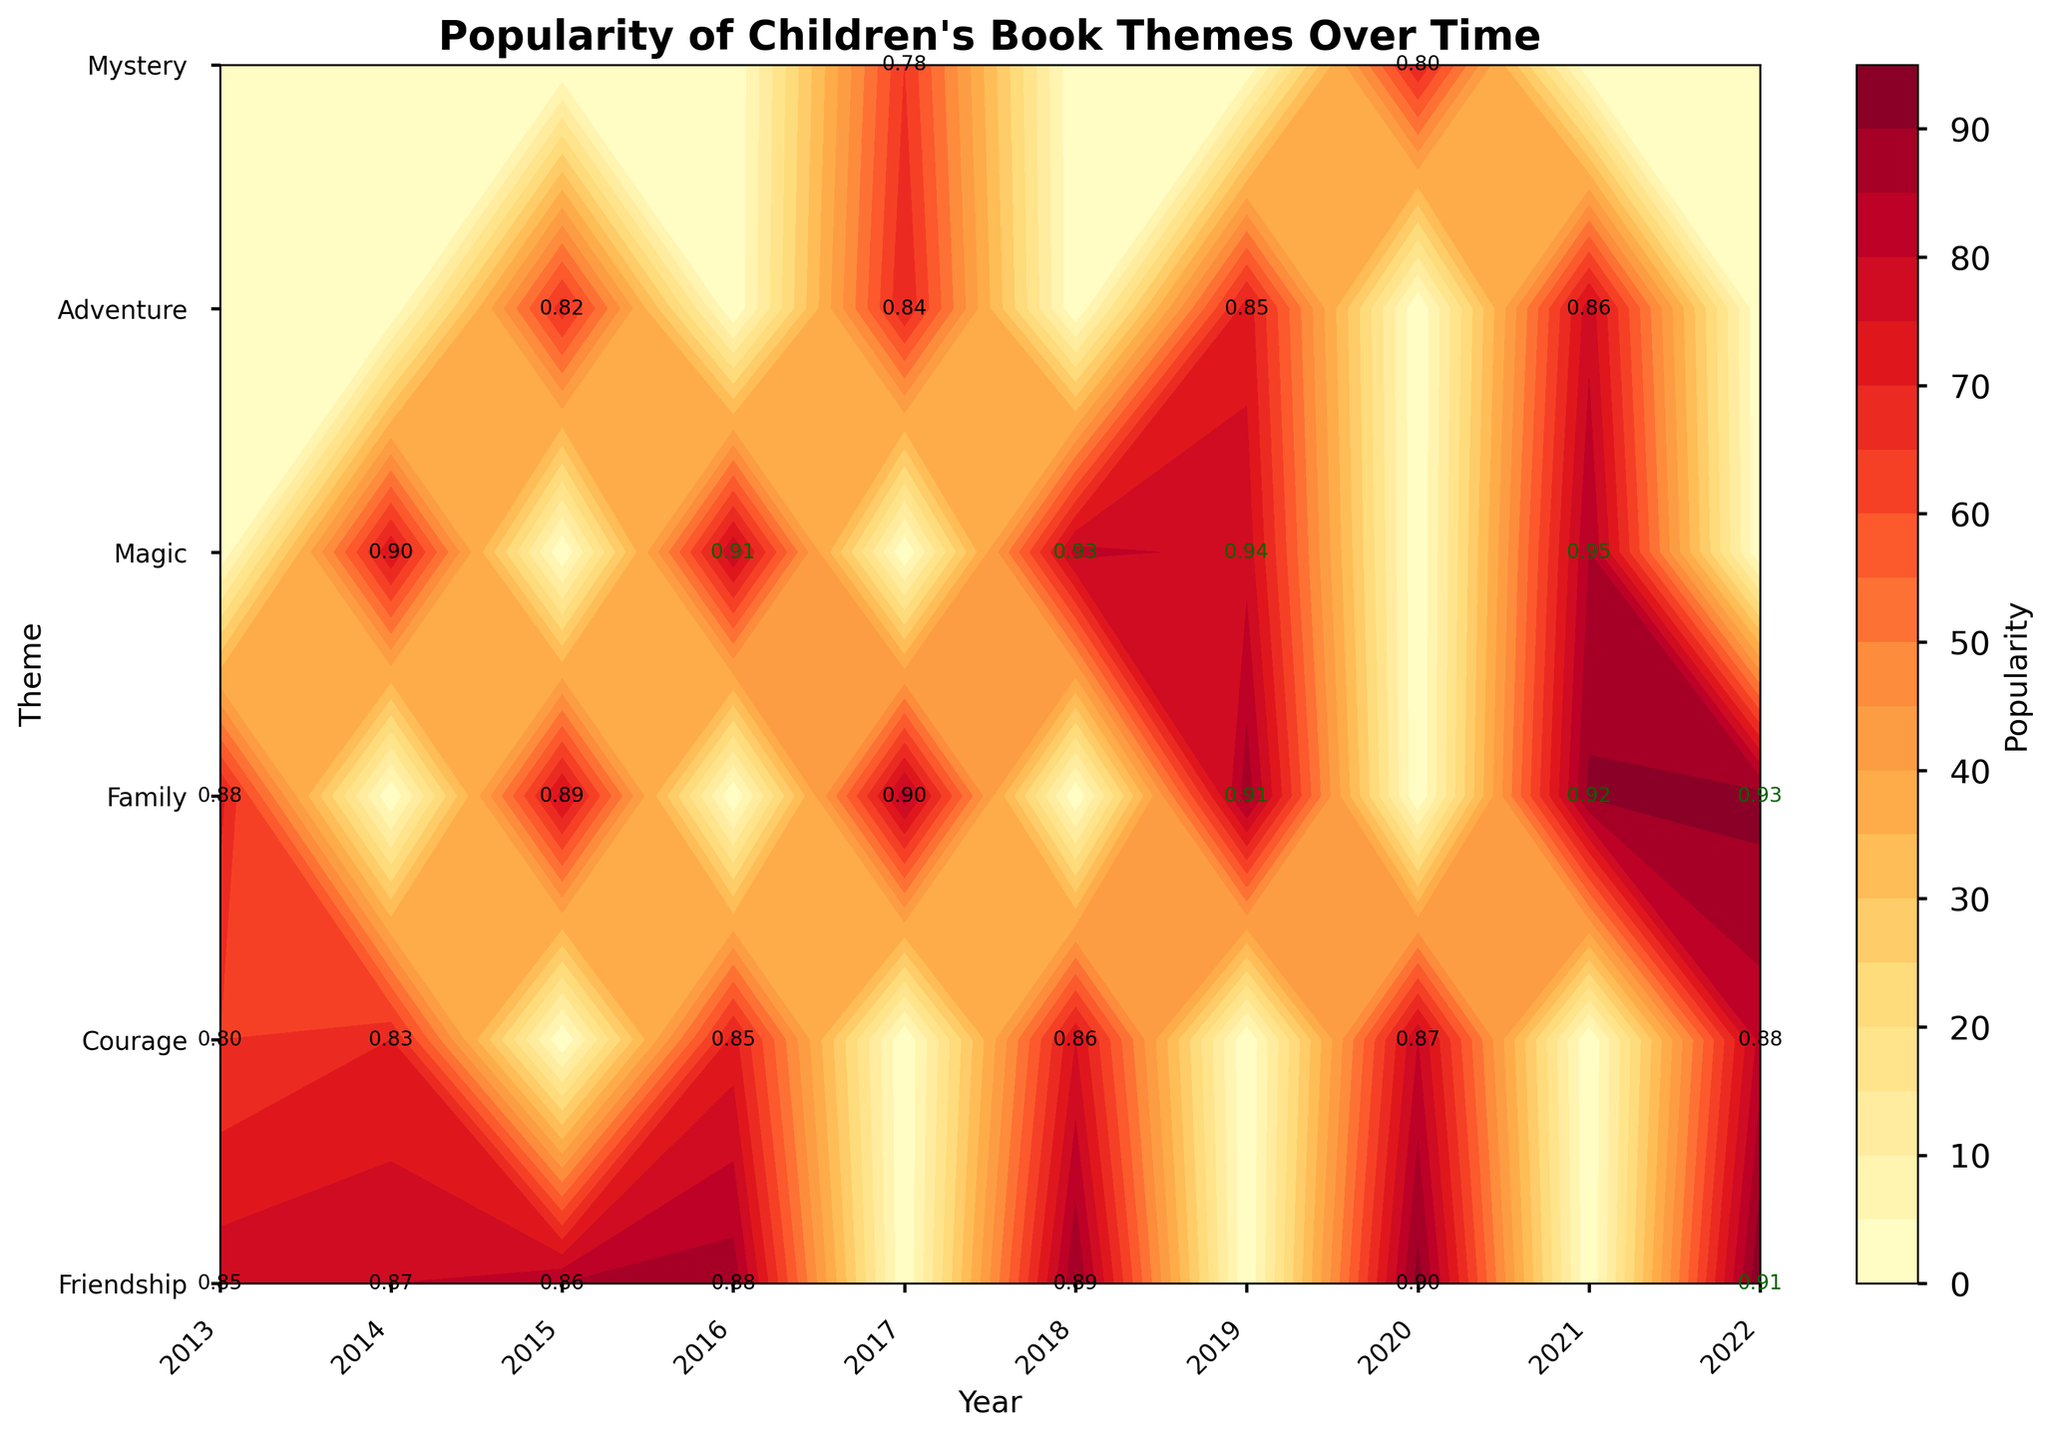What is the title of the figure? The title of the figure is usually displayed at the top of the plot in a bold and larger font, helping to understand what the figure is about.
Answer: Popularity of Children's Book Themes Over Time Which theme appears to have the highest positive sentiment in 2022? By looking at the positive sentiment annotations for the year 2022, the theme with the highest value can be identified.
Answer: Family What is the range of years displayed on the x-axis? The x-axis displays a range of years. By identifying the first and last tick marks on the x-axis, the range can be determined.
Answer: 2013 to 2022 Which theme shows a consistently increasing trend in popularity from 2013 to 2022? By analyzing the contour plot for each theme, you can observe which one has steadily increasing values for popularity over the years.
Answer: Friendship Compare the popularity of the themes "Courage" and "Magic" in 2018. Which one is higher? Locate the popularity values for both "Courage" and "Magic" in the year 2018 from the contour colors or values, then compare them.
Answer: Magic Between the years 2017 and 2020, which theme had the lowest level of positive sentiment, and what was the sentiment value? Examine the positive sentiment annotations in the contour plot for each theme between the years 2017 and 2020 to identify the lowest value.
Answer: Mystery, 0.80 On the contour plot, which color represents the highest popularity? The color corresponding to the highest popularity can be identified from the color bar on the right side of the plot, which indicates the gradient mapping.
Answer: Dark red How does the popularity of the theme "Family" change from 2013 to 2017? Track the popularity levels for the theme "Family" along the years 2013 to 2017 on the contour plot to notice any increases or decreases.
Answer: Increases Which year had the highest overall popularity for the theme "Adventure"? Identify the contour levels for "Adventure" across different years and determine the year with the highest level.
Answer: 2021 Compare the positive sentiment for the theme "Magic" in the years 2016 and 2021. Is it higher or lower in 2021? Locate the positive sentiment values for "Magic" in both years 2016 and 2021 from the annotations and compare them.
Answer: Higher in 2021 